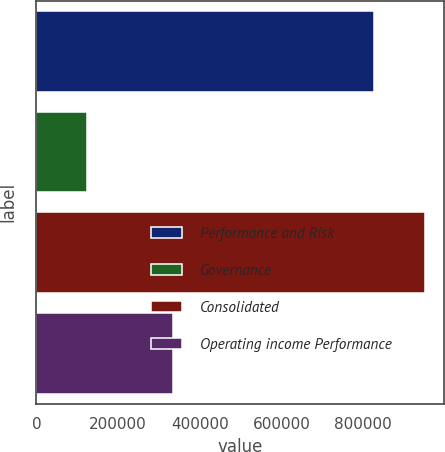Convert chart to OTSL. <chart><loc_0><loc_0><loc_500><loc_500><bar_chart><fcel>Performance and Risk<fcel>Governance<fcel>Consolidated<fcel>Operating income Performance<nl><fcel>826990<fcel>123151<fcel>950141<fcel>334547<nl></chart> 